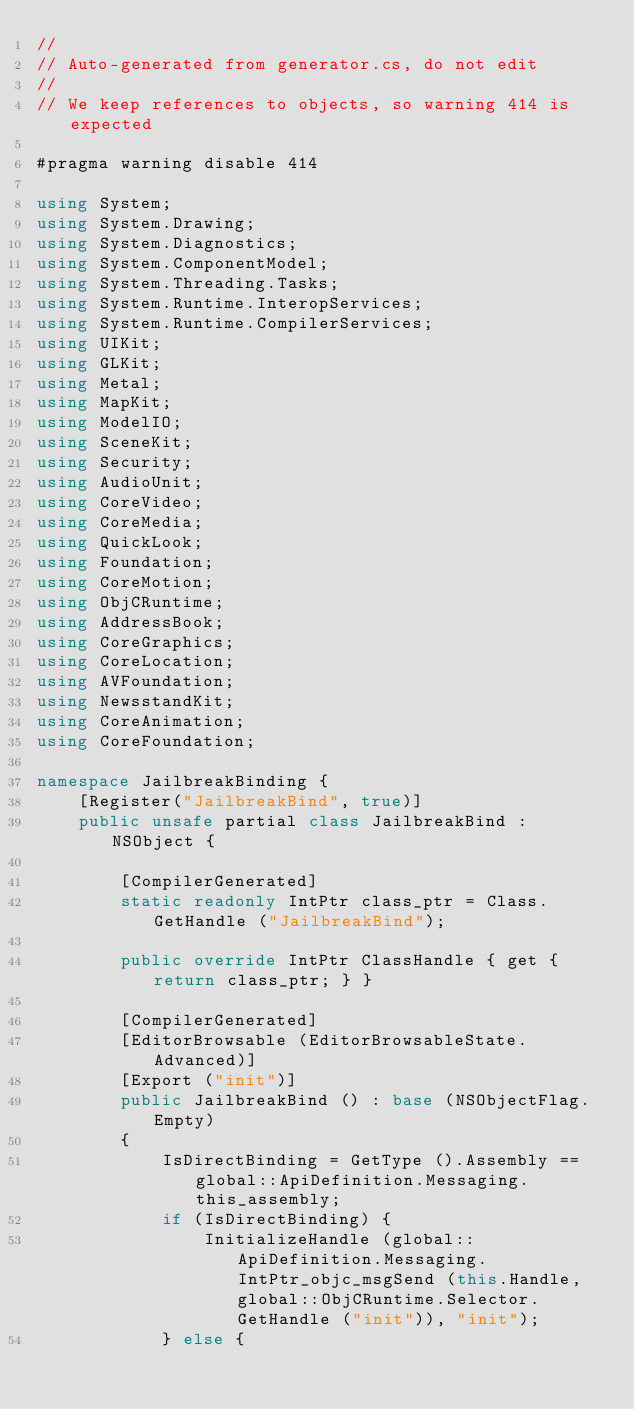Convert code to text. <code><loc_0><loc_0><loc_500><loc_500><_C#_>//
// Auto-generated from generator.cs, do not edit
//
// We keep references to objects, so warning 414 is expected

#pragma warning disable 414

using System;
using System.Drawing;
using System.Diagnostics;
using System.ComponentModel;
using System.Threading.Tasks;
using System.Runtime.InteropServices;
using System.Runtime.CompilerServices;
using UIKit;
using GLKit;
using Metal;
using MapKit;
using ModelIO;
using SceneKit;
using Security;
using AudioUnit;
using CoreVideo;
using CoreMedia;
using QuickLook;
using Foundation;
using CoreMotion;
using ObjCRuntime;
using AddressBook;
using CoreGraphics;
using CoreLocation;
using AVFoundation;
using NewsstandKit;
using CoreAnimation;
using CoreFoundation;

namespace JailbreakBinding {
	[Register("JailbreakBind", true)]
	public unsafe partial class JailbreakBind : NSObject {
		
		[CompilerGenerated]
		static readonly IntPtr class_ptr = Class.GetHandle ("JailbreakBind");
		
		public override IntPtr ClassHandle { get { return class_ptr; } }
		
		[CompilerGenerated]
		[EditorBrowsable (EditorBrowsableState.Advanced)]
		[Export ("init")]
		public JailbreakBind () : base (NSObjectFlag.Empty)
		{
			IsDirectBinding = GetType ().Assembly == global::ApiDefinition.Messaging.this_assembly;
			if (IsDirectBinding) {
				InitializeHandle (global::ApiDefinition.Messaging.IntPtr_objc_msgSend (this.Handle, global::ObjCRuntime.Selector.GetHandle ("init")), "init");
			} else {</code> 